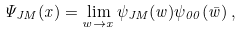Convert formula to latex. <formula><loc_0><loc_0><loc_500><loc_500>\Psi _ { J M } ( x ) = \lim _ { w \rightarrow x } \psi _ { J M } ( w ) \psi _ { 0 0 } ( \bar { w } ) \, ,</formula> 